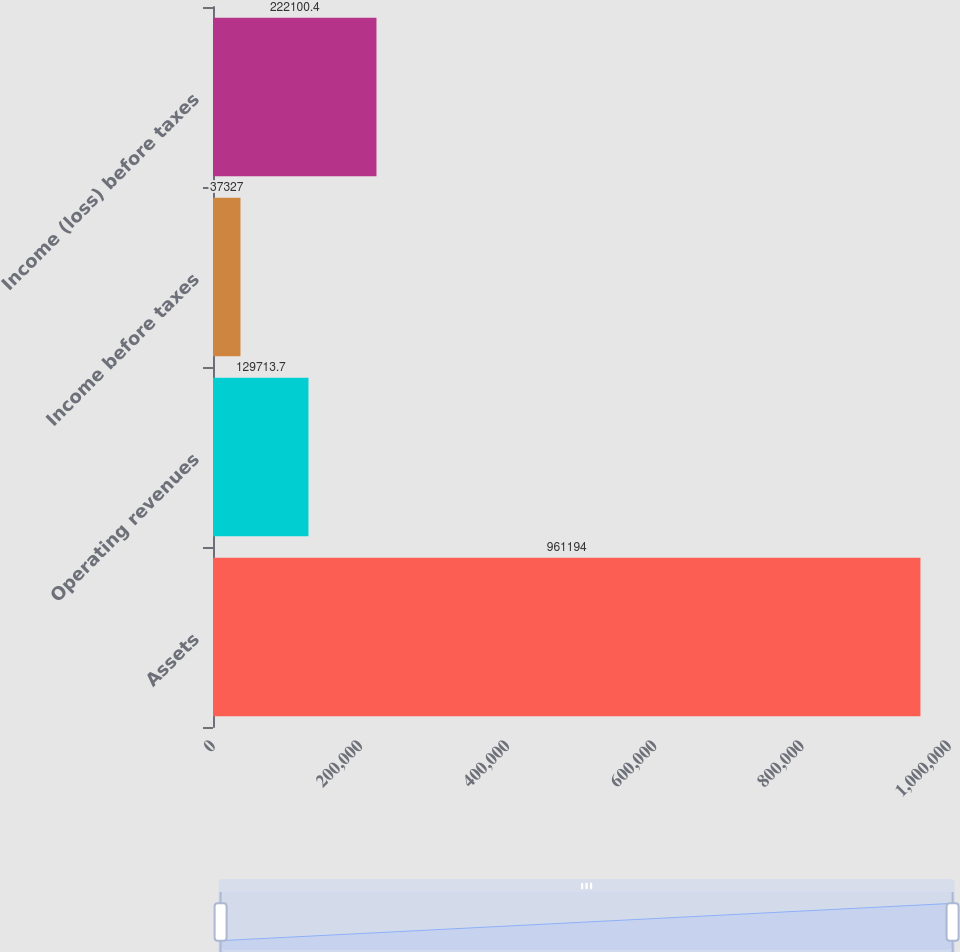<chart> <loc_0><loc_0><loc_500><loc_500><bar_chart><fcel>Assets<fcel>Operating revenues<fcel>Income before taxes<fcel>Income (loss) before taxes<nl><fcel>961194<fcel>129714<fcel>37327<fcel>222100<nl></chart> 